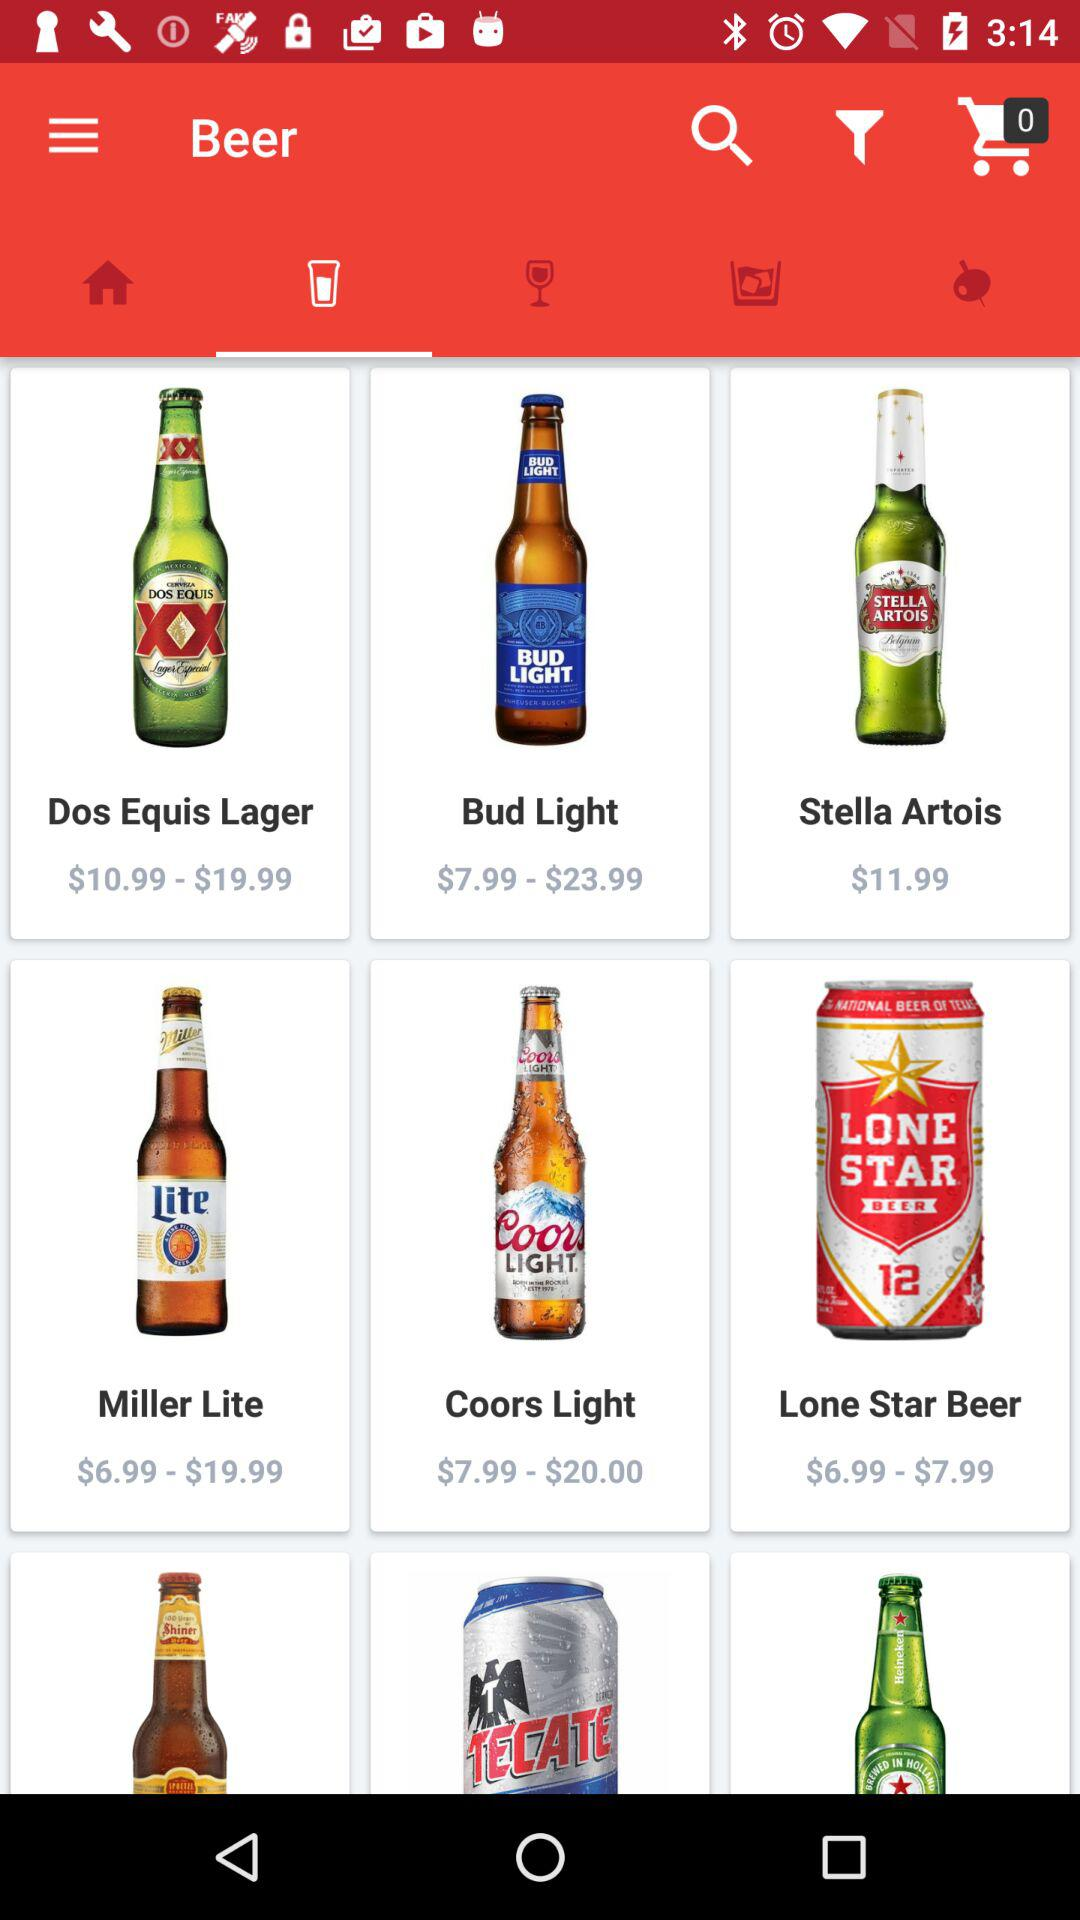What is the price of "Miller Lite" beer? The price ranges from $6.99 to $19.99. 